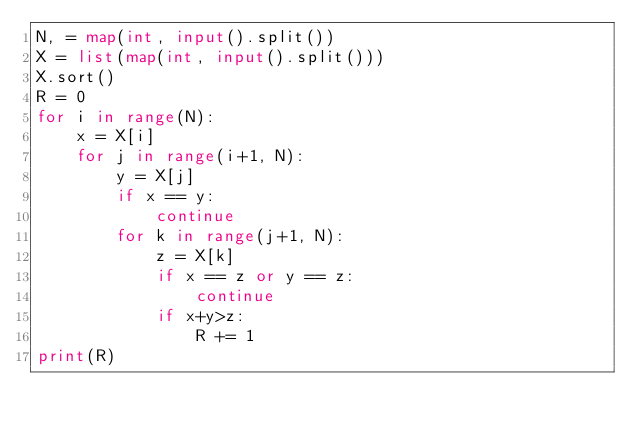<code> <loc_0><loc_0><loc_500><loc_500><_Python_>N, = map(int, input().split())
X = list(map(int, input().split()))
X.sort()
R = 0
for i in range(N):
    x = X[i]
    for j in range(i+1, N):
        y = X[j]
        if x == y:
            continue
        for k in range(j+1, N):
            z = X[k]
            if x == z or y == z:
                continue
            if x+y>z:
                R += 1
print(R)

</code> 